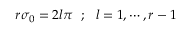Convert formula to latex. <formula><loc_0><loc_0><loc_500><loc_500>r \sigma _ { 0 } = 2 l \pi ; l = 1 , \cdots , r - 1</formula> 